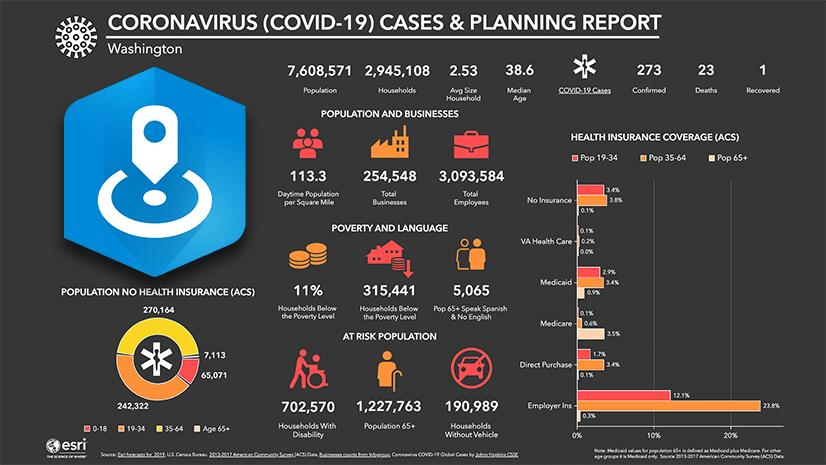Indicate a few pertinent items in this graphic. The population of senior citizens at risk in Washington is 1,227,763. The population of senior citizens who speak Spanish and do not speak English in Washington is 5,065. There are 315,441 households in Washington that are below the poverty line. There are approximately 702,570 households in Washington State that include disabled individuals, as of the most recent data available. There have been 1 recovered case of Covid-19 out of 273 confirmed cases in Washington. 